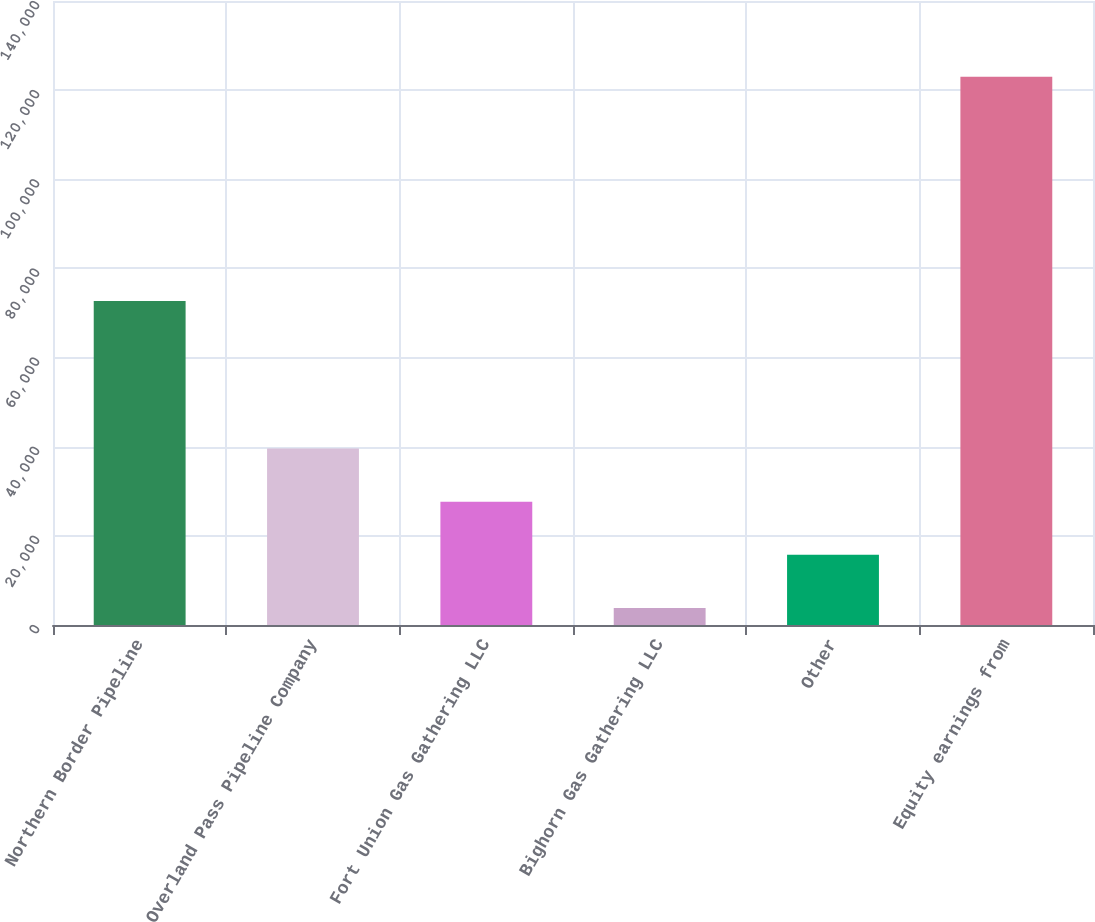Convert chart to OTSL. <chart><loc_0><loc_0><loc_500><loc_500><bar_chart><fcel>Northern Border Pipeline<fcel>Overland Pass Pipeline Company<fcel>Fort Union Gas Gathering LLC<fcel>Bighorn Gas Gathering LLC<fcel>Other<fcel>Equity earnings from<nl><fcel>72705<fcel>39581.2<fcel>27660.8<fcel>3820<fcel>15740.4<fcel>123024<nl></chart> 